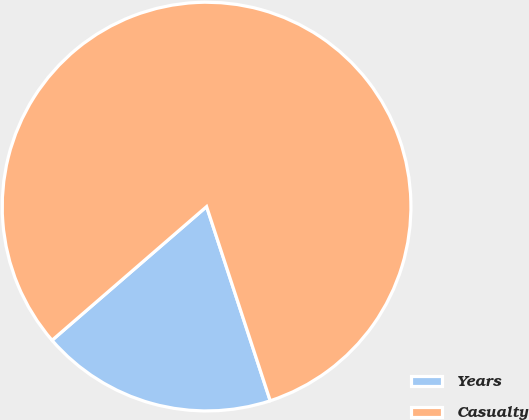<chart> <loc_0><loc_0><loc_500><loc_500><pie_chart><fcel>Years<fcel>Casualty<nl><fcel>18.69%<fcel>81.31%<nl></chart> 